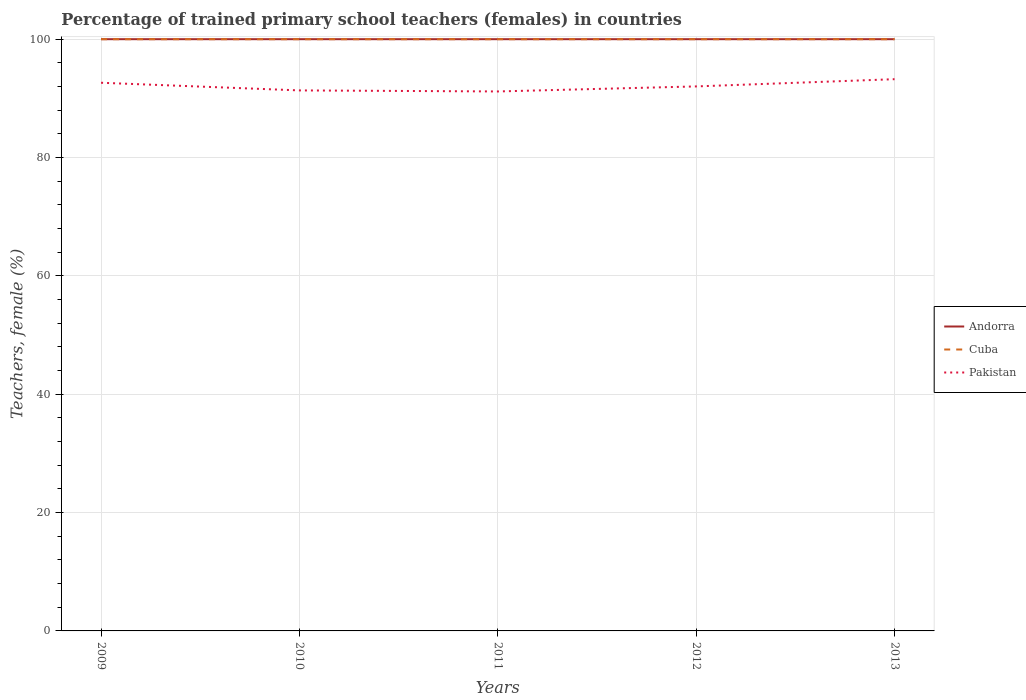How many different coloured lines are there?
Your response must be concise. 3. Across all years, what is the maximum percentage of trained primary school teachers (females) in Pakistan?
Give a very brief answer. 91.17. What is the difference between the highest and the second highest percentage of trained primary school teachers (females) in Cuba?
Keep it short and to the point. 0. What is the difference between the highest and the lowest percentage of trained primary school teachers (females) in Pakistan?
Offer a very short reply. 2. Is the percentage of trained primary school teachers (females) in Pakistan strictly greater than the percentage of trained primary school teachers (females) in Andorra over the years?
Provide a short and direct response. Yes. How many lines are there?
Ensure brevity in your answer.  3. Does the graph contain grids?
Provide a short and direct response. Yes. Where does the legend appear in the graph?
Offer a very short reply. Center right. How are the legend labels stacked?
Offer a very short reply. Vertical. What is the title of the graph?
Your response must be concise. Percentage of trained primary school teachers (females) in countries. What is the label or title of the X-axis?
Give a very brief answer. Years. What is the label or title of the Y-axis?
Keep it short and to the point. Teachers, female (%). What is the Teachers, female (%) in Cuba in 2009?
Offer a very short reply. 100. What is the Teachers, female (%) in Pakistan in 2009?
Give a very brief answer. 92.64. What is the Teachers, female (%) in Pakistan in 2010?
Offer a terse response. 91.34. What is the Teachers, female (%) of Pakistan in 2011?
Give a very brief answer. 91.17. What is the Teachers, female (%) in Andorra in 2012?
Offer a terse response. 100. What is the Teachers, female (%) in Cuba in 2012?
Your answer should be very brief. 100. What is the Teachers, female (%) of Pakistan in 2012?
Make the answer very short. 92.02. What is the Teachers, female (%) of Cuba in 2013?
Make the answer very short. 100. What is the Teachers, female (%) in Pakistan in 2013?
Make the answer very short. 93.24. Across all years, what is the maximum Teachers, female (%) of Pakistan?
Offer a very short reply. 93.24. Across all years, what is the minimum Teachers, female (%) in Cuba?
Your answer should be very brief. 100. Across all years, what is the minimum Teachers, female (%) of Pakistan?
Your answer should be very brief. 91.17. What is the total Teachers, female (%) in Pakistan in the graph?
Provide a succinct answer. 460.41. What is the difference between the Teachers, female (%) in Cuba in 2009 and that in 2010?
Provide a succinct answer. 0. What is the difference between the Teachers, female (%) in Pakistan in 2009 and that in 2010?
Provide a succinct answer. 1.29. What is the difference between the Teachers, female (%) in Pakistan in 2009 and that in 2011?
Provide a short and direct response. 1.47. What is the difference between the Teachers, female (%) of Pakistan in 2009 and that in 2012?
Give a very brief answer. 0.62. What is the difference between the Teachers, female (%) in Andorra in 2009 and that in 2013?
Give a very brief answer. 0. What is the difference between the Teachers, female (%) in Pakistan in 2009 and that in 2013?
Your answer should be compact. -0.6. What is the difference between the Teachers, female (%) in Andorra in 2010 and that in 2011?
Give a very brief answer. 0. What is the difference between the Teachers, female (%) of Pakistan in 2010 and that in 2011?
Make the answer very short. 0.18. What is the difference between the Teachers, female (%) in Andorra in 2010 and that in 2012?
Ensure brevity in your answer.  0. What is the difference between the Teachers, female (%) of Pakistan in 2010 and that in 2012?
Your answer should be very brief. -0.68. What is the difference between the Teachers, female (%) of Cuba in 2010 and that in 2013?
Ensure brevity in your answer.  0. What is the difference between the Teachers, female (%) in Pakistan in 2010 and that in 2013?
Ensure brevity in your answer.  -1.9. What is the difference between the Teachers, female (%) of Cuba in 2011 and that in 2012?
Keep it short and to the point. 0. What is the difference between the Teachers, female (%) in Pakistan in 2011 and that in 2012?
Provide a succinct answer. -0.85. What is the difference between the Teachers, female (%) in Pakistan in 2011 and that in 2013?
Your answer should be very brief. -2.07. What is the difference between the Teachers, female (%) in Pakistan in 2012 and that in 2013?
Give a very brief answer. -1.22. What is the difference between the Teachers, female (%) of Andorra in 2009 and the Teachers, female (%) of Cuba in 2010?
Provide a short and direct response. 0. What is the difference between the Teachers, female (%) in Andorra in 2009 and the Teachers, female (%) in Pakistan in 2010?
Your answer should be very brief. 8.66. What is the difference between the Teachers, female (%) in Cuba in 2009 and the Teachers, female (%) in Pakistan in 2010?
Ensure brevity in your answer.  8.66. What is the difference between the Teachers, female (%) in Andorra in 2009 and the Teachers, female (%) in Cuba in 2011?
Make the answer very short. 0. What is the difference between the Teachers, female (%) in Andorra in 2009 and the Teachers, female (%) in Pakistan in 2011?
Your response must be concise. 8.83. What is the difference between the Teachers, female (%) in Cuba in 2009 and the Teachers, female (%) in Pakistan in 2011?
Give a very brief answer. 8.83. What is the difference between the Teachers, female (%) in Andorra in 2009 and the Teachers, female (%) in Pakistan in 2012?
Offer a terse response. 7.98. What is the difference between the Teachers, female (%) of Cuba in 2009 and the Teachers, female (%) of Pakistan in 2012?
Offer a terse response. 7.98. What is the difference between the Teachers, female (%) of Andorra in 2009 and the Teachers, female (%) of Pakistan in 2013?
Offer a terse response. 6.76. What is the difference between the Teachers, female (%) in Cuba in 2009 and the Teachers, female (%) in Pakistan in 2013?
Offer a very short reply. 6.76. What is the difference between the Teachers, female (%) in Andorra in 2010 and the Teachers, female (%) in Cuba in 2011?
Your response must be concise. 0. What is the difference between the Teachers, female (%) of Andorra in 2010 and the Teachers, female (%) of Pakistan in 2011?
Provide a succinct answer. 8.83. What is the difference between the Teachers, female (%) of Cuba in 2010 and the Teachers, female (%) of Pakistan in 2011?
Keep it short and to the point. 8.83. What is the difference between the Teachers, female (%) of Andorra in 2010 and the Teachers, female (%) of Cuba in 2012?
Provide a short and direct response. 0. What is the difference between the Teachers, female (%) of Andorra in 2010 and the Teachers, female (%) of Pakistan in 2012?
Keep it short and to the point. 7.98. What is the difference between the Teachers, female (%) in Cuba in 2010 and the Teachers, female (%) in Pakistan in 2012?
Keep it short and to the point. 7.98. What is the difference between the Teachers, female (%) of Andorra in 2010 and the Teachers, female (%) of Cuba in 2013?
Keep it short and to the point. 0. What is the difference between the Teachers, female (%) of Andorra in 2010 and the Teachers, female (%) of Pakistan in 2013?
Make the answer very short. 6.76. What is the difference between the Teachers, female (%) of Cuba in 2010 and the Teachers, female (%) of Pakistan in 2013?
Keep it short and to the point. 6.76. What is the difference between the Teachers, female (%) in Andorra in 2011 and the Teachers, female (%) in Cuba in 2012?
Your response must be concise. 0. What is the difference between the Teachers, female (%) of Andorra in 2011 and the Teachers, female (%) of Pakistan in 2012?
Offer a terse response. 7.98. What is the difference between the Teachers, female (%) in Cuba in 2011 and the Teachers, female (%) in Pakistan in 2012?
Your answer should be compact. 7.98. What is the difference between the Teachers, female (%) of Andorra in 2011 and the Teachers, female (%) of Cuba in 2013?
Offer a terse response. 0. What is the difference between the Teachers, female (%) of Andorra in 2011 and the Teachers, female (%) of Pakistan in 2013?
Offer a very short reply. 6.76. What is the difference between the Teachers, female (%) in Cuba in 2011 and the Teachers, female (%) in Pakistan in 2013?
Provide a succinct answer. 6.76. What is the difference between the Teachers, female (%) in Andorra in 2012 and the Teachers, female (%) in Cuba in 2013?
Ensure brevity in your answer.  0. What is the difference between the Teachers, female (%) of Andorra in 2012 and the Teachers, female (%) of Pakistan in 2013?
Your answer should be compact. 6.76. What is the difference between the Teachers, female (%) of Cuba in 2012 and the Teachers, female (%) of Pakistan in 2013?
Make the answer very short. 6.76. What is the average Teachers, female (%) in Pakistan per year?
Offer a terse response. 92.08. In the year 2009, what is the difference between the Teachers, female (%) of Andorra and Teachers, female (%) of Cuba?
Keep it short and to the point. 0. In the year 2009, what is the difference between the Teachers, female (%) of Andorra and Teachers, female (%) of Pakistan?
Provide a short and direct response. 7.36. In the year 2009, what is the difference between the Teachers, female (%) of Cuba and Teachers, female (%) of Pakistan?
Your response must be concise. 7.36. In the year 2010, what is the difference between the Teachers, female (%) of Andorra and Teachers, female (%) of Pakistan?
Offer a terse response. 8.66. In the year 2010, what is the difference between the Teachers, female (%) in Cuba and Teachers, female (%) in Pakistan?
Provide a succinct answer. 8.66. In the year 2011, what is the difference between the Teachers, female (%) of Andorra and Teachers, female (%) of Cuba?
Offer a terse response. 0. In the year 2011, what is the difference between the Teachers, female (%) in Andorra and Teachers, female (%) in Pakistan?
Provide a succinct answer. 8.83. In the year 2011, what is the difference between the Teachers, female (%) in Cuba and Teachers, female (%) in Pakistan?
Offer a terse response. 8.83. In the year 2012, what is the difference between the Teachers, female (%) of Andorra and Teachers, female (%) of Cuba?
Keep it short and to the point. 0. In the year 2012, what is the difference between the Teachers, female (%) of Andorra and Teachers, female (%) of Pakistan?
Provide a succinct answer. 7.98. In the year 2012, what is the difference between the Teachers, female (%) in Cuba and Teachers, female (%) in Pakistan?
Your answer should be compact. 7.98. In the year 2013, what is the difference between the Teachers, female (%) of Andorra and Teachers, female (%) of Pakistan?
Offer a very short reply. 6.76. In the year 2013, what is the difference between the Teachers, female (%) in Cuba and Teachers, female (%) in Pakistan?
Your answer should be compact. 6.76. What is the ratio of the Teachers, female (%) of Pakistan in 2009 to that in 2010?
Your answer should be very brief. 1.01. What is the ratio of the Teachers, female (%) in Pakistan in 2009 to that in 2011?
Ensure brevity in your answer.  1.02. What is the ratio of the Teachers, female (%) in Andorra in 2009 to that in 2012?
Ensure brevity in your answer.  1. What is the ratio of the Teachers, female (%) of Cuba in 2009 to that in 2013?
Provide a succinct answer. 1. What is the ratio of the Teachers, female (%) in Pakistan in 2009 to that in 2013?
Your answer should be compact. 0.99. What is the ratio of the Teachers, female (%) in Andorra in 2010 to that in 2011?
Ensure brevity in your answer.  1. What is the ratio of the Teachers, female (%) of Andorra in 2010 to that in 2012?
Your answer should be very brief. 1. What is the ratio of the Teachers, female (%) of Pakistan in 2010 to that in 2012?
Your answer should be compact. 0.99. What is the ratio of the Teachers, female (%) of Andorra in 2010 to that in 2013?
Provide a succinct answer. 1. What is the ratio of the Teachers, female (%) of Cuba in 2010 to that in 2013?
Your answer should be very brief. 1. What is the ratio of the Teachers, female (%) in Pakistan in 2010 to that in 2013?
Provide a short and direct response. 0.98. What is the ratio of the Teachers, female (%) of Andorra in 2011 to that in 2012?
Your response must be concise. 1. What is the ratio of the Teachers, female (%) in Pakistan in 2011 to that in 2013?
Your response must be concise. 0.98. What is the ratio of the Teachers, female (%) of Andorra in 2012 to that in 2013?
Give a very brief answer. 1. What is the ratio of the Teachers, female (%) of Pakistan in 2012 to that in 2013?
Keep it short and to the point. 0.99. What is the difference between the highest and the second highest Teachers, female (%) in Pakistan?
Offer a terse response. 0.6. What is the difference between the highest and the lowest Teachers, female (%) in Cuba?
Your answer should be very brief. 0. What is the difference between the highest and the lowest Teachers, female (%) of Pakistan?
Your response must be concise. 2.07. 